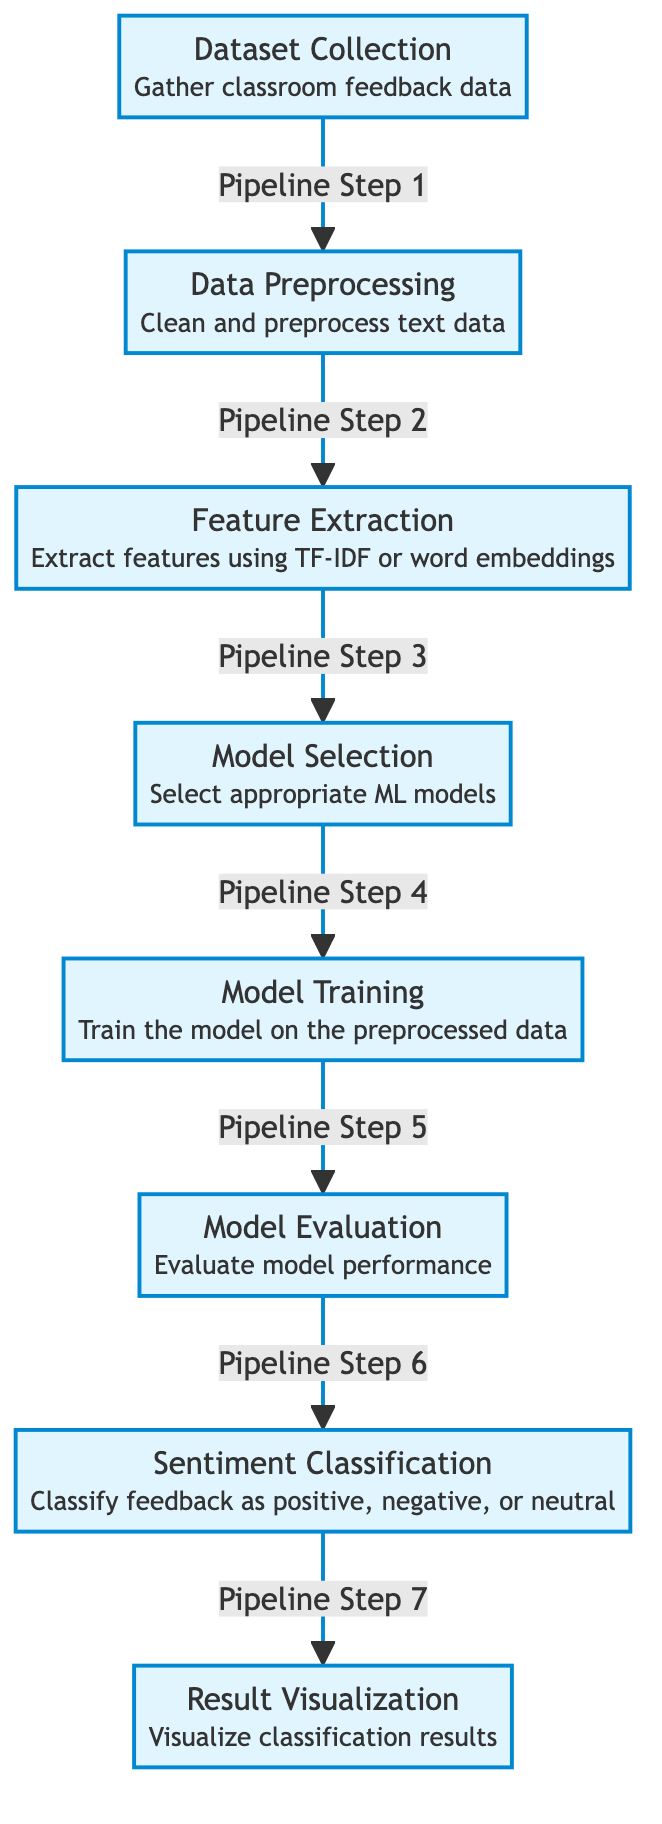What is the first step in the pipeline? The first step shown in the diagram is "Dataset Collection," which involves gathering classroom feedback data. The diagram clearly indicates this as the starting point.
Answer: Dataset Collection How many steps are there in total? By examining the flow of the diagram, there are a total of seven distinct steps in the process, from dataset collection to result visualization.
Answer: Seven What does the “Model Evaluation” step assess? The "Model Evaluation" step is focused on assessing the performance of the model trained on the preprocessed data. This involves analyzing how well the model performs its task of classifying sentiment.
Answer: Model performance Which step follows “Data Preprocessing”? Following "Data Preprocessing," the next step is "Feature Extraction," where key features are extracted using techniques like TF-IDF or word embeddings as indicated in the flow.
Answer: Feature Extraction In the context of this diagram, which term describes the role of the "Classification" step? The "Classification" step in this context refers to the act of categorizing feedback into sentiment classes, specifically as positive, negative, or neutral. It is a critical stage in the sentiment analysis process.
Answer: Sentiment Classification What process comes before "Result Visualization"? The step that precedes "Result Visualization" is "Sentiment Classification," where the categorized feedback is classified based on the sentiment extracted from the classroom reviews.
Answer: Sentiment Classification What technique is mentioned for feature extraction? The diagram specifies two techniques mentioned for feature extraction: TF-IDF and word embeddings, which are both popular methods for transforming text data into meaningful features.
Answer: TF-IDF or word embeddings What is the main goal of the entire pipeline? The main goal of the entire pipeline is to classify student feedback regarding different classes and professors into sentiment categories (positive, negative, or neutral) based on the processed data.
Answer: Sentiment Classification 